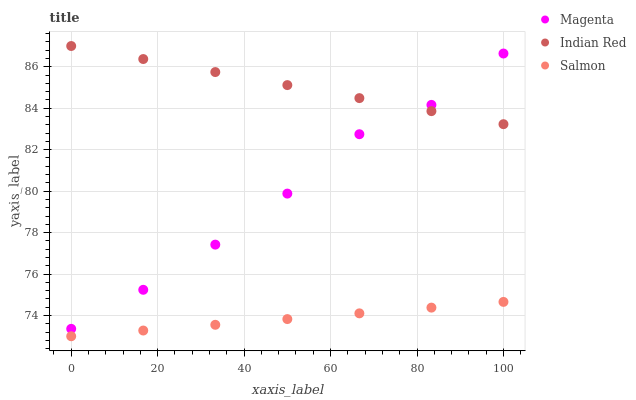Does Salmon have the minimum area under the curve?
Answer yes or no. Yes. Does Indian Red have the maximum area under the curve?
Answer yes or no. Yes. Does Indian Red have the minimum area under the curve?
Answer yes or no. No. Does Salmon have the maximum area under the curve?
Answer yes or no. No. Is Salmon the smoothest?
Answer yes or no. Yes. Is Magenta the roughest?
Answer yes or no. Yes. Is Indian Red the smoothest?
Answer yes or no. No. Is Indian Red the roughest?
Answer yes or no. No. Does Salmon have the lowest value?
Answer yes or no. Yes. Does Indian Red have the lowest value?
Answer yes or no. No. Does Indian Red have the highest value?
Answer yes or no. Yes. Does Salmon have the highest value?
Answer yes or no. No. Is Salmon less than Magenta?
Answer yes or no. Yes. Is Magenta greater than Salmon?
Answer yes or no. Yes. Does Magenta intersect Indian Red?
Answer yes or no. Yes. Is Magenta less than Indian Red?
Answer yes or no. No. Is Magenta greater than Indian Red?
Answer yes or no. No. Does Salmon intersect Magenta?
Answer yes or no. No. 